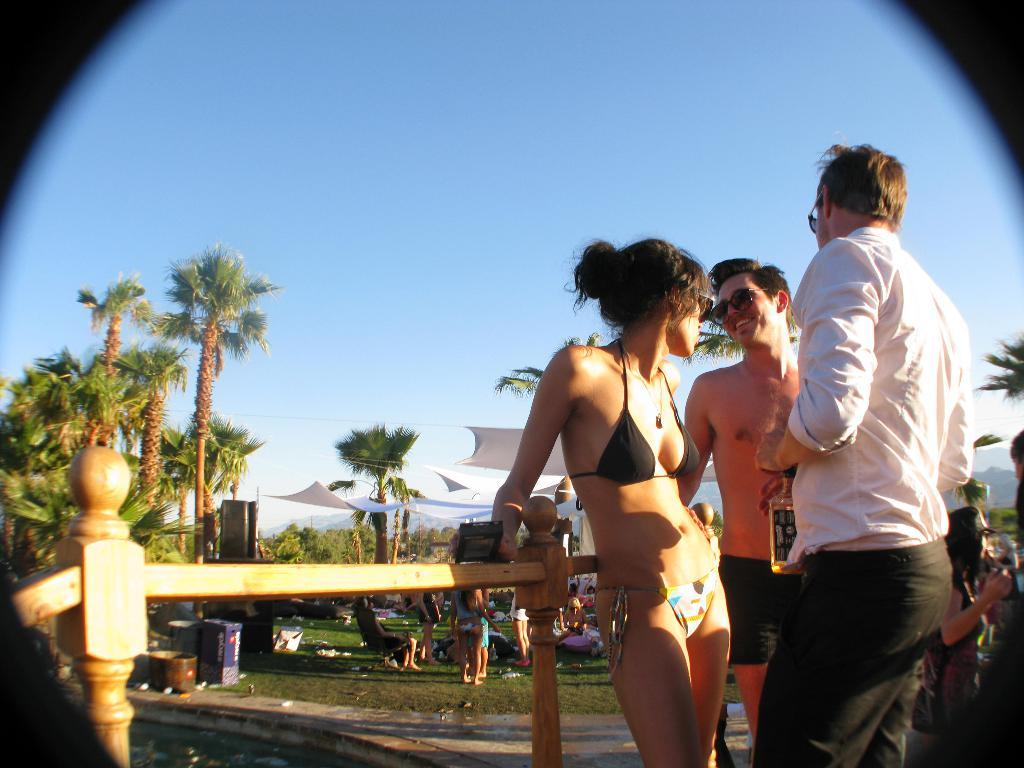How many people are in the image? There are people in the image, but the exact number is not specified. What is one person holding in the image? One person is holding something in the image. What type of natural vegetation can be seen in the image? There are trees in the image. What type of barrier is present in the image? There is fencing in the image. What color are the clothes of some people in the image? White color clothes are visible in the image. What type of objects can be seen in the image? There are objects in the image. What is the color of the sky in the image? The sky is blue in color. What type of condition is the brush in the image? There is no brush present in the image. How does the lock function in the image? There is no lock present in the image. 